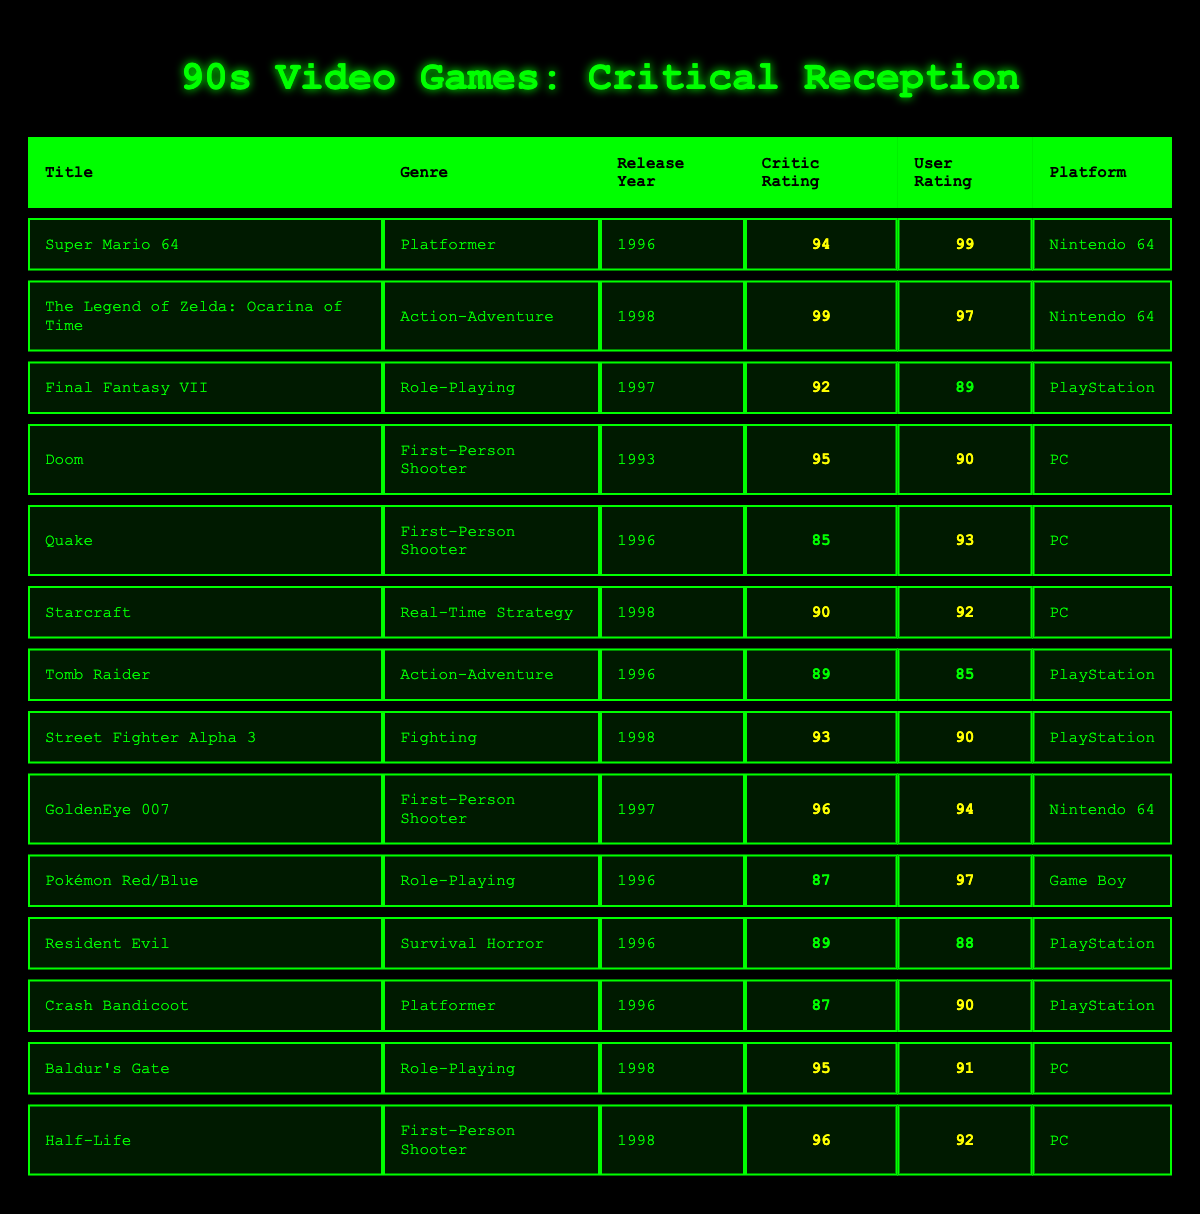What is the title of the video game with the highest critic rating? The highest critic rating in the table is 99, and it corresponds to "The Legend of Zelda: Ocarina of Time."
Answer: The Legend of Zelda: Ocarina of Time Which genre has the most games listed in the table? By counting the entries for each genre, "First-Person Shooter" has 4 games (Doom, Quake, GoldenEye 007, and Half-Life) while others have fewer, making it the most represented genre.
Answer: First-Person Shooter What is the user rating of "Final Fantasy VII"? Looking at the row for "Final Fantasy VII," it shows a user rating of 89.
Answer: 89 Which game was released in 1996 and has a user rating of 90 or higher? Checking each game released in 1996, both "Super Mario 64" (user rating 99) and "Crash Bandicoot" (user rating 90) meet the criteria.
Answer: Super Mario 64, Crash Bandicoot What is the average critic rating of all Role-Playing games? The critic ratings for Role-Playing games are 92 (Final Fantasy VII), 87 (Pokémon Red/Blue), and 95 (Baldur's Gate). Adding these (92 + 87 + 95 = 274) and dividing by 3 gives an average of about 91.33.
Answer: 91.33 Is "Street Fighter Alpha 3" rated higher by critics than "Doom"? "Street Fighter Alpha 3" has a critic rating of 93 while "Doom" has a critic rating of 95. Since 93 is less than 95, the statement is false.
Answer: No Which game has the highest user rating and what is that rating? The game with the highest user rating is "Super Mario 64," with a user rating of 99.
Answer: 99 How many games were released in 1998, and what are their titles? Counting the games released in 1998, there are 5: "The Legend of Zelda: Ocarina of Time," "Starcraft," "Street Fighter Alpha 3," "Baldur's Gate," and "Half-Life."
Answer: 5 (The Legend of Zelda: Ocarina of Time, Starcraft, Street Fighter Alpha 3, Baldur's Gate, Half-Life) Is the critic rating for "Tomb Raider" less than the average critic rating of all First-Person Shooter games? The critic ratings for First-Person Shooters are 95 (Doom), 85 (Quake), 96 (GoldenEye 007), and 96 (Half-Life), averaging to 93.75. "Tomb Raider" has a critic rating of 89, which is indeed less than 93.75.
Answer: Yes What are the platforms of the games listed under the Action-Adventure genre? The platforms for the Action-Adventure games "The Legend of Zelda: Ocarina of Time" and "Tomb Raider" are both Nintendo 64 and PlayStation, respectively.
Answer: Nintendo 64, PlayStation 